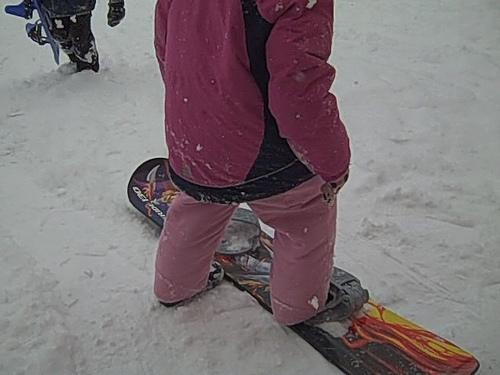Explain the task which deals with answering questions based on the image. The Visual Question Answering (VQA) task involves answering questions based on the information and objects present in the image. Provide a brief summary of the overall scene in this image. The image features a snowy scene with people wearing winter gear and snowboarding. Describe the color and type of clothing worn by the people in the snow. The person in the snow is wearing a pink winter coat and pink pants. Provide a count of all objects in the image. There are a total of 5 objects captured in this image. Can you count the total number of baseball players in this image? There are no baseball players in this image. What objects are involved in the object interaction analysis task? The snowboard on the ground and the person standing on the snowboard are involved in the object interaction analysis task. What task involves figuring out the quality of the image? The image quality assessment task is about figuring out the quality of the image. Analyze the sentiment of the scene portrayed in the image. The scene has a joyful and adventurous sentiment with people engaging in winter sports such as snowboarding. Could you help me identify the tall giraffe standing on the left side of the orange and red house? There is no giraffe or house visible in this image. 